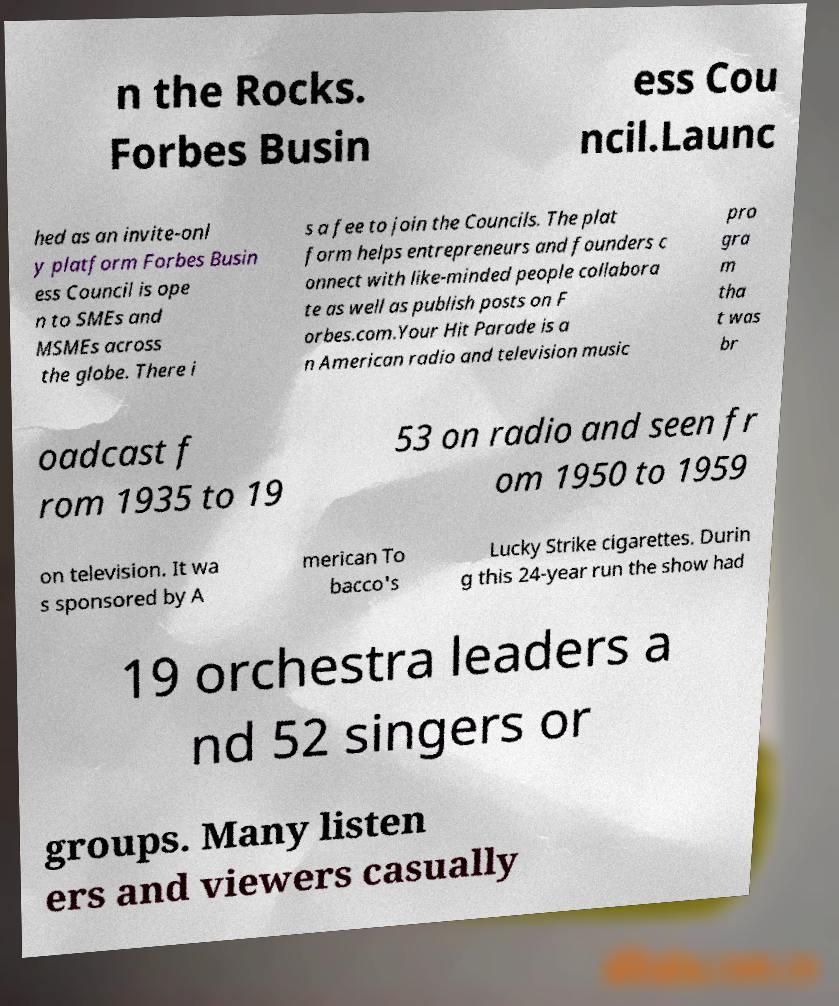What messages or text are displayed in this image? I need them in a readable, typed format. n the Rocks. Forbes Busin ess Cou ncil.Launc hed as an invite-onl y platform Forbes Busin ess Council is ope n to SMEs and MSMEs across the globe. There i s a fee to join the Councils. The plat form helps entrepreneurs and founders c onnect with like-minded people collabora te as well as publish posts on F orbes.com.Your Hit Parade is a n American radio and television music pro gra m tha t was br oadcast f rom 1935 to 19 53 on radio and seen fr om 1950 to 1959 on television. It wa s sponsored by A merican To bacco's Lucky Strike cigarettes. Durin g this 24-year run the show had 19 orchestra leaders a nd 52 singers or groups. Many listen ers and viewers casually 